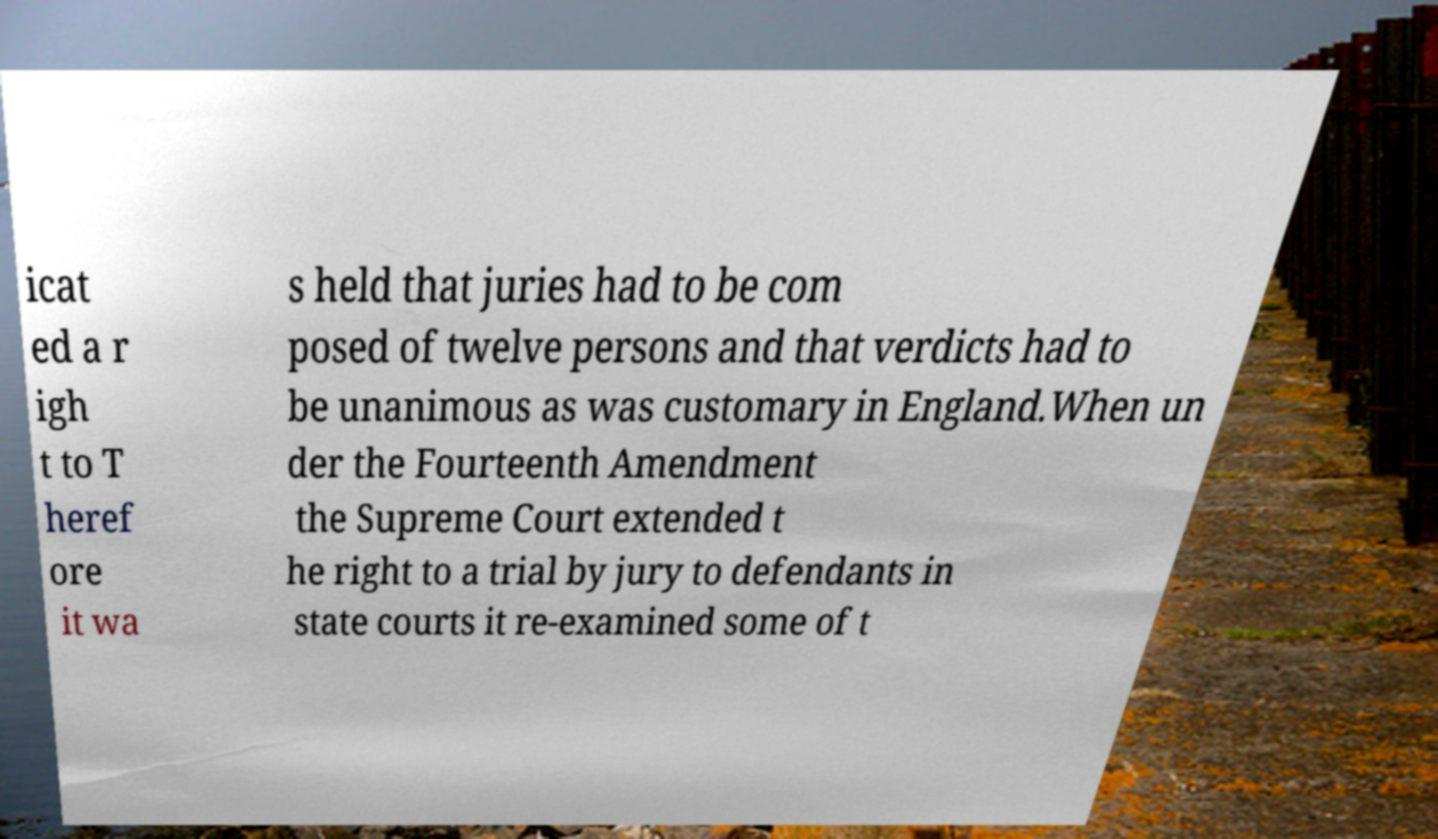Could you extract and type out the text from this image? icat ed a r igh t to T heref ore it wa s held that juries had to be com posed of twelve persons and that verdicts had to be unanimous as was customary in England.When un der the Fourteenth Amendment the Supreme Court extended t he right to a trial by jury to defendants in state courts it re-examined some of t 